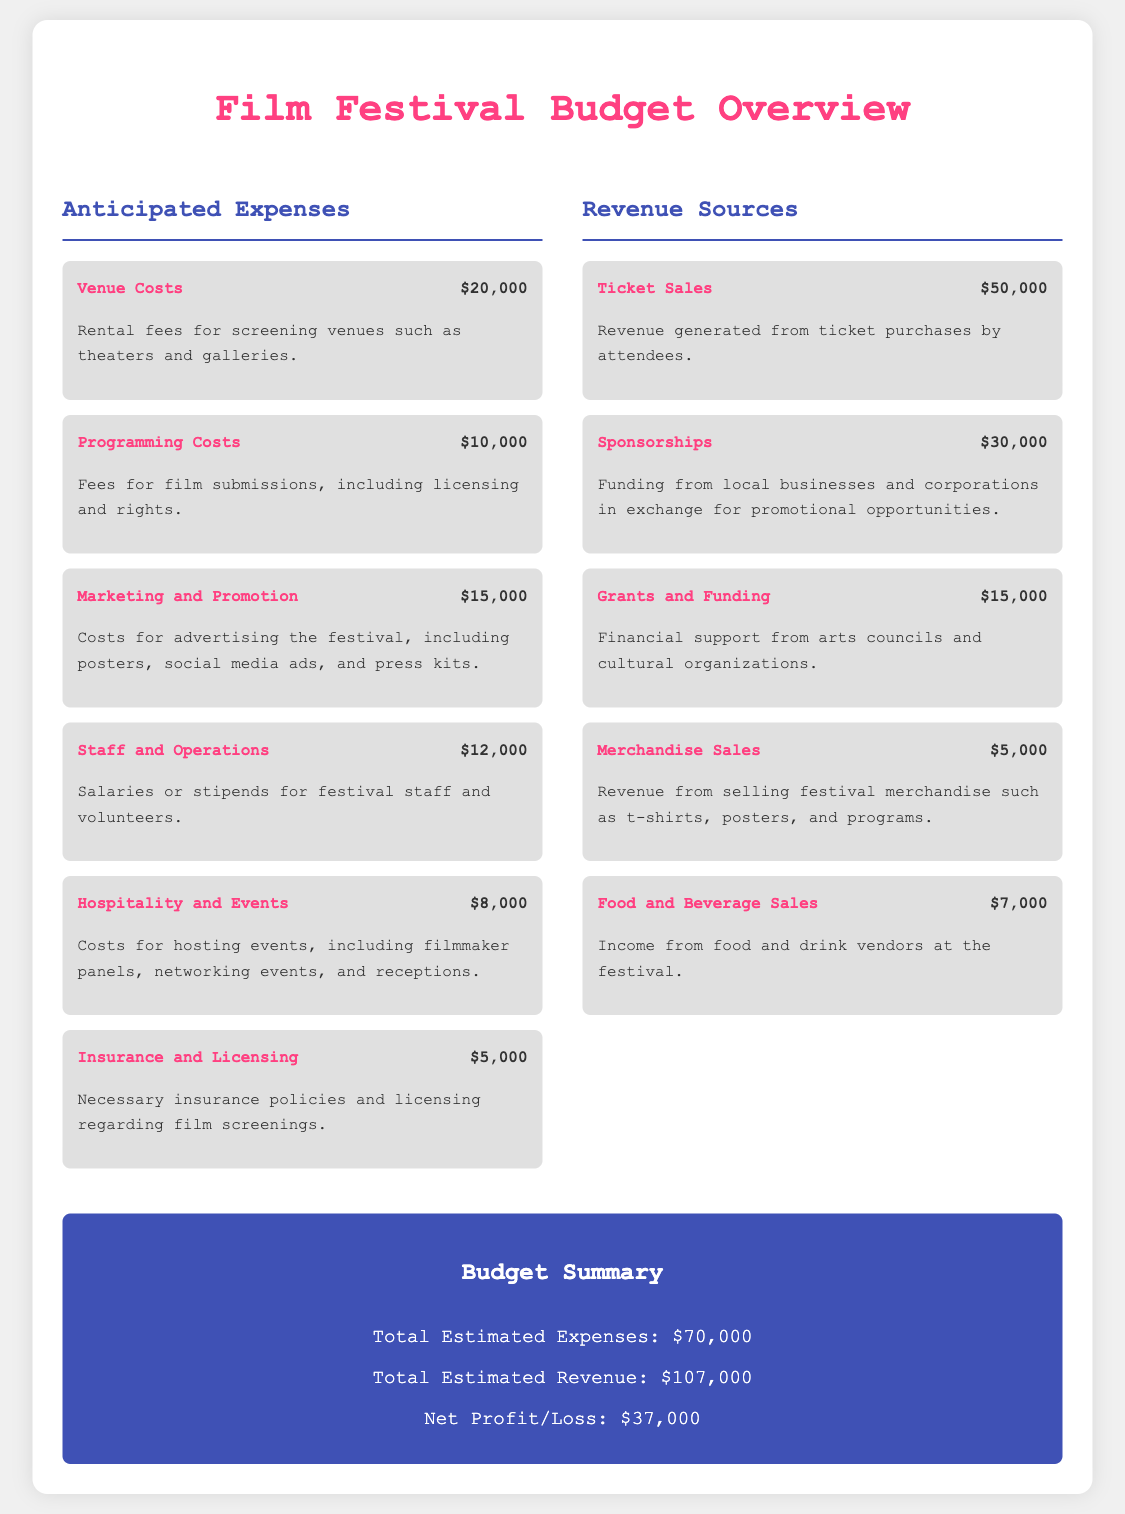What are the total anticipated expenses? The total anticipated expenses are presented as a summary in the document, which adds up to $70,000.
Answer: $70,000 What is the cost for marketing and promotion? The marketing and promotion costs are listed under anticipated expenses as $15,000.
Answer: $15,000 How much revenue is expected from ticket sales? The expected revenue from ticket sales is detailed in the revenue section of the document as $50,000.
Answer: $50,000 What is the net profit/loss for the festival? The net profit/loss is calculated as total estimated revenue minus total estimated expenses, which is $37,000.
Answer: $37,000 What percentage of the total revenue comes from sponsorships? Sponsorships account for $30,000 of the total revenue, which is $107,000, making it approximately 28.04%.
Answer: 28.04% What are the two highest anticipated expenses? The two highest anticipated expenses are venue costs and marketing and promotion.
Answer: Venue costs and marketing and promotion What is the least expensive revenue source listed? The least expensive revenue source listed in the budget is merchandise sales at $5,000.
Answer: $5,000 How much is allocated for hospitality and events? The document states that $8,000 is allocated for hospitality and events under the anticipated expenses.
Answer: $8,000 What type of costs are included under insurance and licensing? Insurance and licensing costs are necessary insurance policies and licensing related to film screenings.
Answer: Necessary insurance policies and licensing 